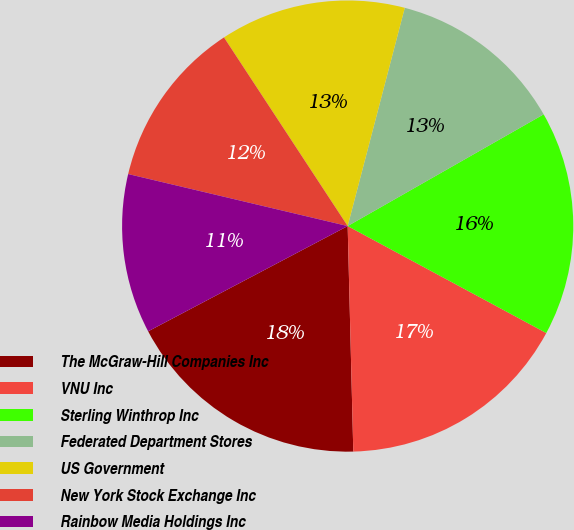Convert chart to OTSL. <chart><loc_0><loc_0><loc_500><loc_500><pie_chart><fcel>The McGraw-Hill Companies Inc<fcel>VNU Inc<fcel>Sterling Winthrop Inc<fcel>Federated Department Stores<fcel>US Government<fcel>New York Stock Exchange Inc<fcel>Rainbow Media Holdings Inc<nl><fcel>17.67%<fcel>16.74%<fcel>16.11%<fcel>12.68%<fcel>13.31%<fcel>12.06%<fcel>11.43%<nl></chart> 